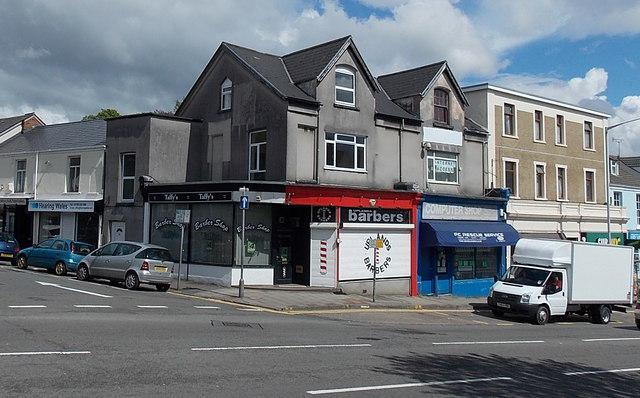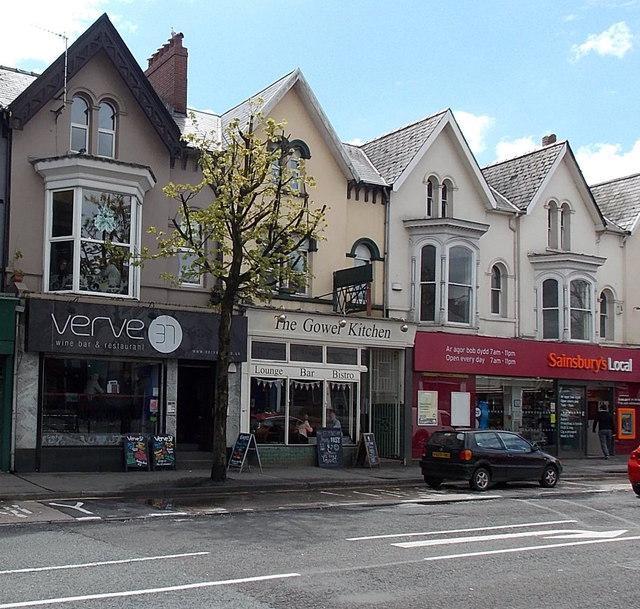The first image is the image on the left, the second image is the image on the right. Given the left and right images, does the statement "A truck is visible in one image, and at least one car is visible in each image." hold true? Answer yes or no. Yes. The first image is the image on the left, the second image is the image on the right. Examine the images to the left and right. Is the description "There is at least one barber pole in the image on the right" accurate? Answer yes or no. No. 